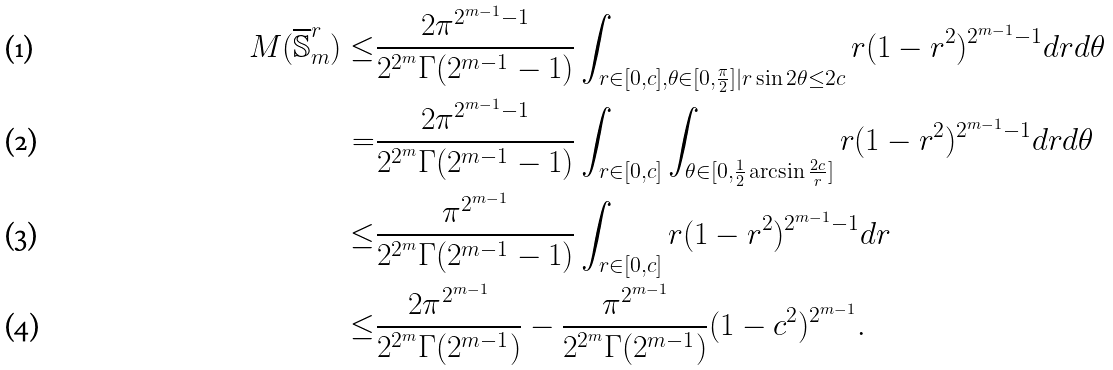Convert formula to latex. <formula><loc_0><loc_0><loc_500><loc_500>M ( \overline { \mathbb { S } } _ { m } ^ { r } ) \leq & \frac { 2 \pi ^ { 2 ^ { m - 1 } - 1 } } { 2 ^ { 2 ^ { m } } \Gamma ( 2 ^ { m - 1 } - 1 ) } \int _ { r \in [ 0 , c ] , \theta \in [ 0 , \frac { \pi } { 2 } ] | r \sin 2 \theta \leq 2 c } r ( 1 - r ^ { 2 } ) ^ { 2 ^ { m - 1 } - 1 } d r d \theta \\ = & \frac { 2 \pi ^ { 2 ^ { m - 1 } - 1 } } { 2 ^ { 2 ^ { m } } \Gamma ( 2 ^ { m - 1 } - 1 ) } \int _ { r \in [ 0 , c ] } \int _ { \theta \in [ 0 , \frac { 1 } { 2 } \arcsin \frac { 2 c } { r } ] } r ( 1 - r ^ { 2 } ) ^ { 2 ^ { m - 1 } - 1 } d r d \theta \\ \leq & \frac { \pi ^ { 2 ^ { m - 1 } } } { 2 ^ { 2 ^ { m } } \Gamma ( 2 ^ { m - 1 } - 1 ) } \int _ { r \in [ 0 , c ] } r ( 1 - r ^ { 2 } ) ^ { 2 ^ { m - 1 } - 1 } d r \\ \leq & \frac { 2 \pi ^ { 2 ^ { m - 1 } } } { 2 ^ { 2 ^ { m } } \Gamma ( 2 ^ { m - 1 } ) } - \frac { \pi ^ { 2 ^ { m - 1 } } } { 2 ^ { 2 ^ { m } } \Gamma ( 2 ^ { m - 1 } ) } ( 1 - c ^ { 2 } ) ^ { 2 ^ { m - 1 } } .</formula> 